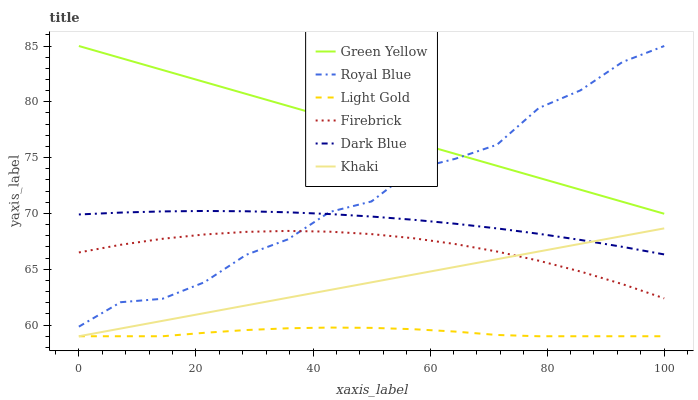Does Dark Blue have the minimum area under the curve?
Answer yes or no. No. Does Dark Blue have the maximum area under the curve?
Answer yes or no. No. Is Dark Blue the smoothest?
Answer yes or no. No. Is Dark Blue the roughest?
Answer yes or no. No. Does Dark Blue have the lowest value?
Answer yes or no. No. Does Dark Blue have the highest value?
Answer yes or no. No. Is Firebrick less than Green Yellow?
Answer yes or no. Yes. Is Royal Blue greater than Khaki?
Answer yes or no. Yes. Does Firebrick intersect Green Yellow?
Answer yes or no. No. 